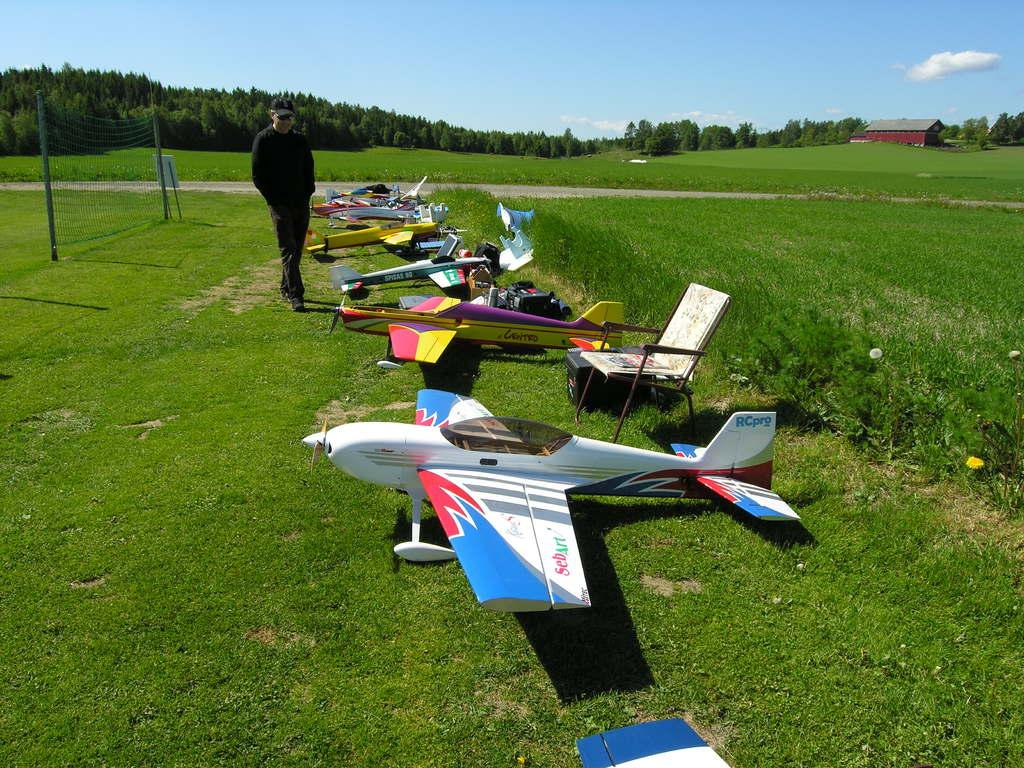What type of vehicles are on the grass in the image? There are demo airplanes on the grass in the image. Can you describe the person in the image? There is a person standing in the image. What piece of furniture is present in the image? There is a chair in the image. What object is used for separating or dividing in the image? There is a net in the image. What type of vegetation is visible in the image? There are trees in the image. What type of building is in the image? There is a house in the image. What is visible in the background of the image? The sky is visible in the background of the image. What is the income of the person standing in the image? There is no information about the person's income in the image. Where is the mailbox located in the image? There is no mailbox present in the image. 